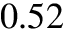<formula> <loc_0><loc_0><loc_500><loc_500>0 . 5 2</formula> 